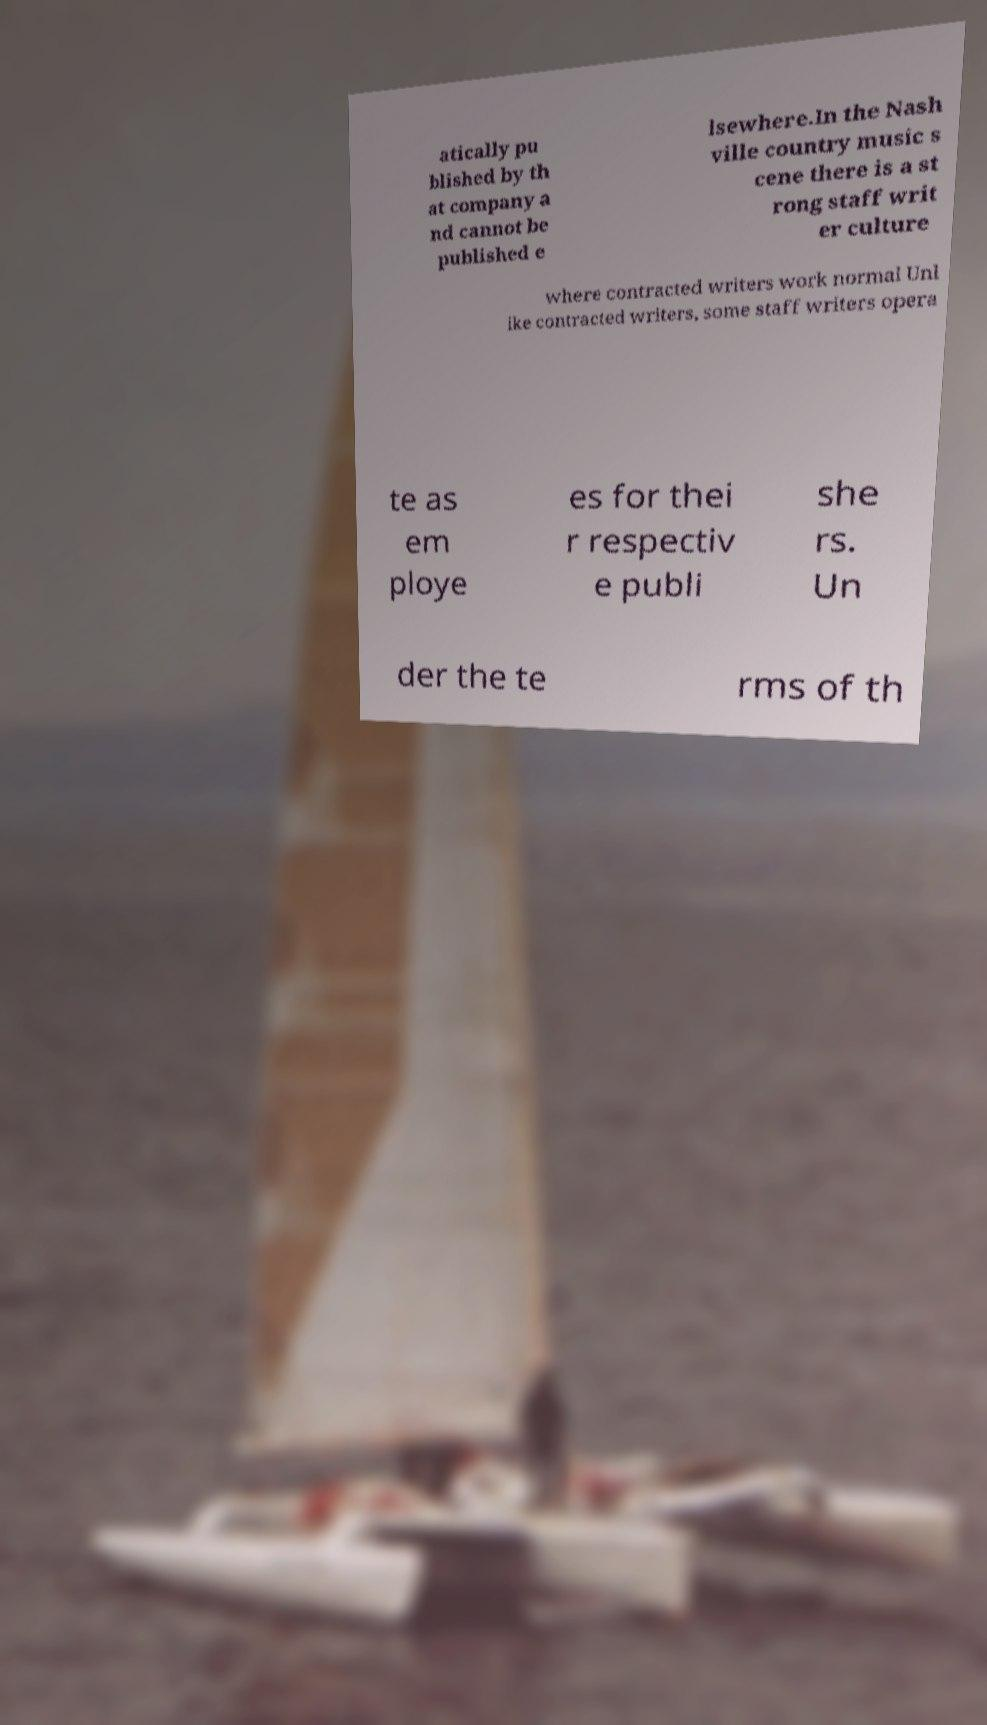There's text embedded in this image that I need extracted. Can you transcribe it verbatim? atically pu blished by th at company a nd cannot be published e lsewhere.In the Nash ville country music s cene there is a st rong staff writ er culture where contracted writers work normal Unl ike contracted writers, some staff writers opera te as em ploye es for thei r respectiv e publi she rs. Un der the te rms of th 